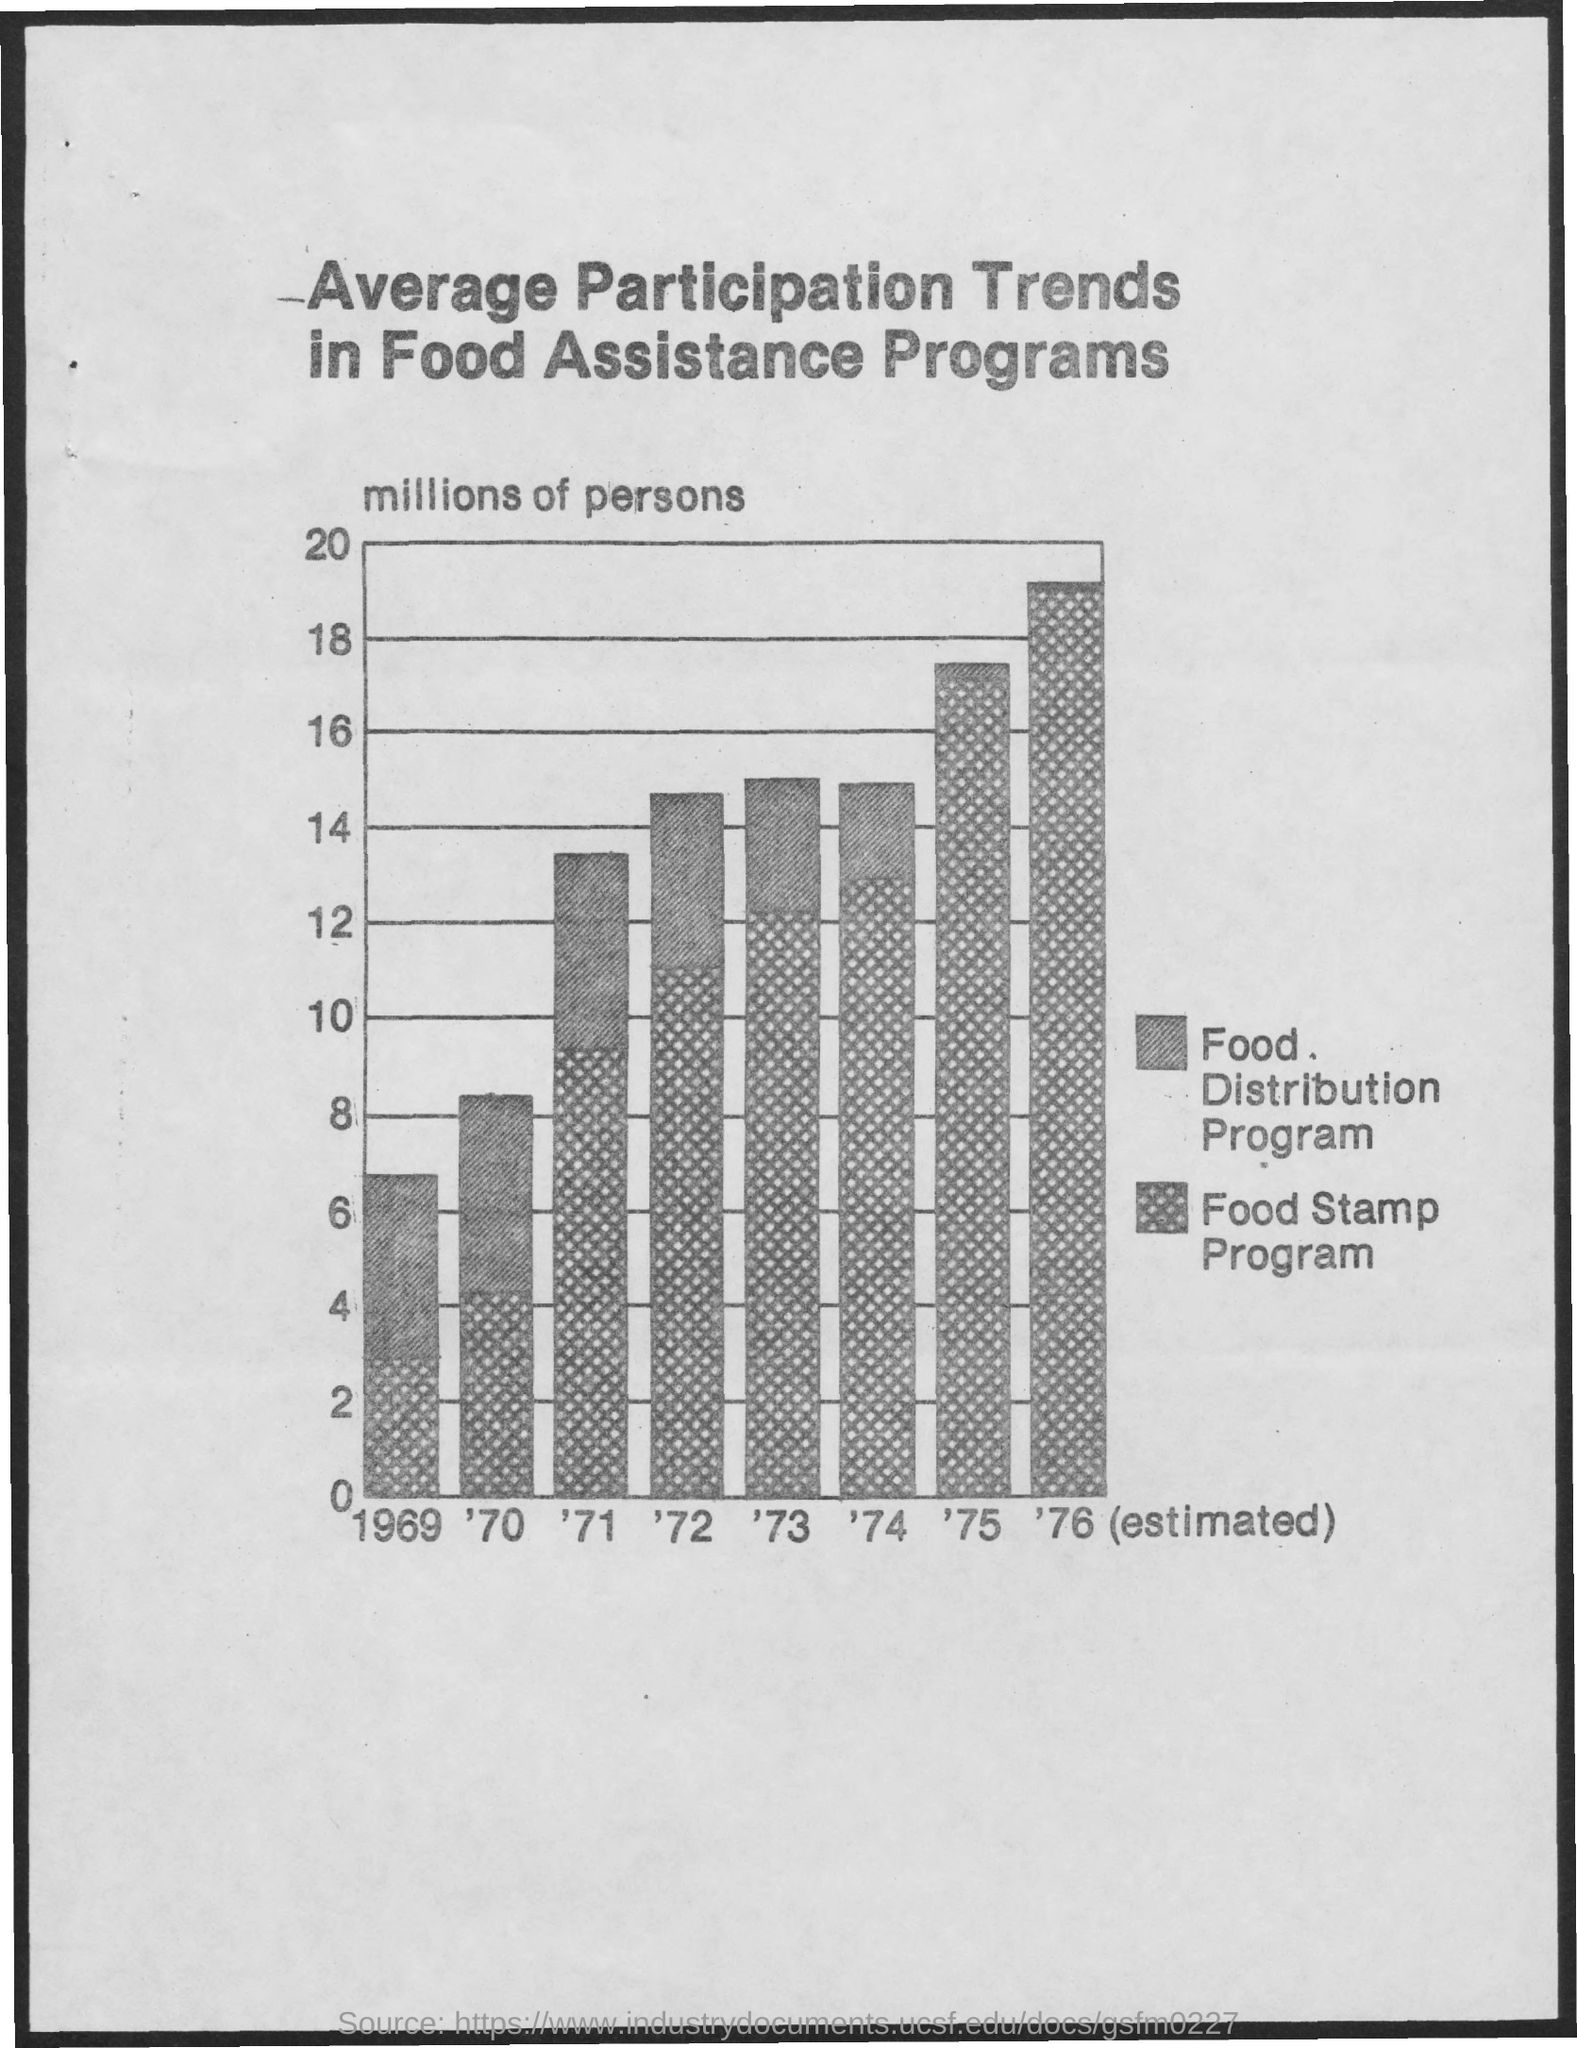Indicate a few pertinent items in this graphic. The Food Stamp Program was at its maximum in 1976. The title of the document is 'Average Participation Trends in Food Assistance Programs.' The Food Stamp Program was established in 1969. 